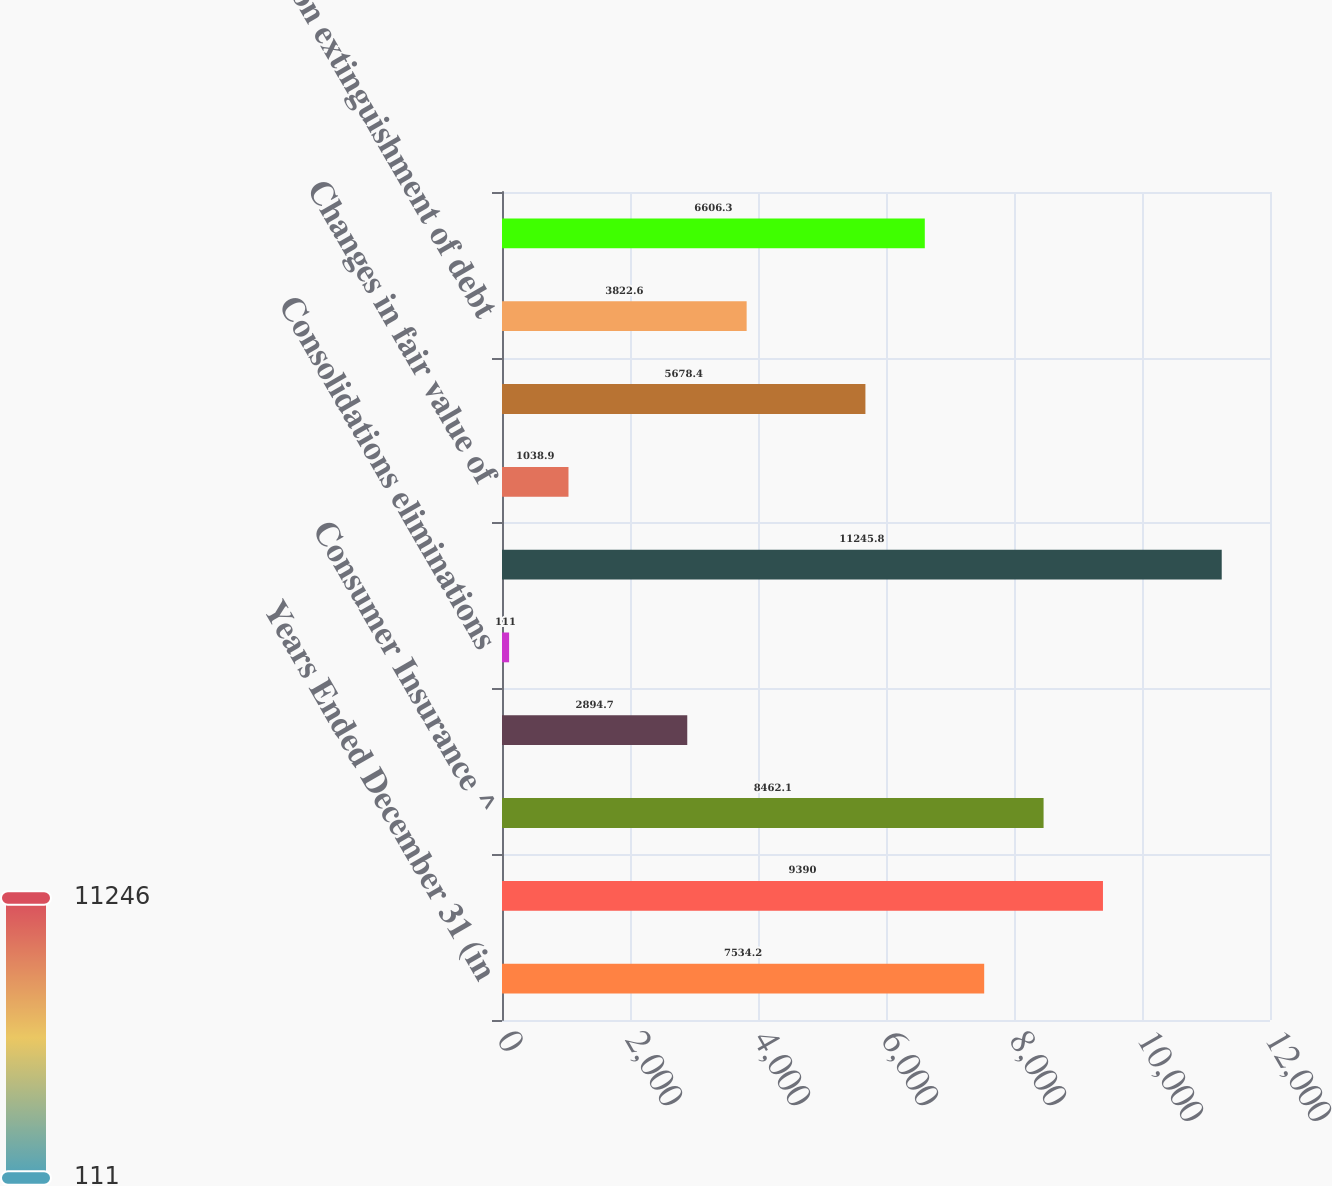Convert chart. <chart><loc_0><loc_0><loc_500><loc_500><bar_chart><fcel>Years Ended December 31 (in<fcel>Commercial Insurance ^<fcel>Consumer Insurance ^<fcel>Corporate and Other<fcel>Consolidations eliminations<fcel>Pre-tax operating income<fcel>Changes in fair value of<fcel>SIA related to net realized<fcel>Loss on extinguishment of debt<fcel>Net realized capital gains<nl><fcel>7534.2<fcel>9390<fcel>8462.1<fcel>2894.7<fcel>111<fcel>11245.8<fcel>1038.9<fcel>5678.4<fcel>3822.6<fcel>6606.3<nl></chart> 